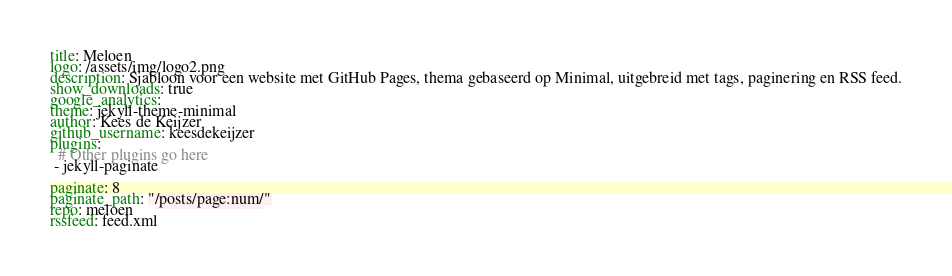<code> <loc_0><loc_0><loc_500><loc_500><_YAML_>title: Meloen
logo: /assets/img/logo2.png
description: Sjabloon voor een website met GitHub Pages, thema gebaseerd op Minimal, uitgebreid met tags, paginering en RSS feed.
show_downloads: true
google_analytics:
theme: jekyll-theme-minimal
author: Kees de Keijzer
github_username: keesdekeijzer
plugins:
  # Other plugins go here
 - jekyll-paginate

paginate: 8
paginate_path: "/posts/page:num/"
repo: meloen
rssfeed: feed.xml
</code> 